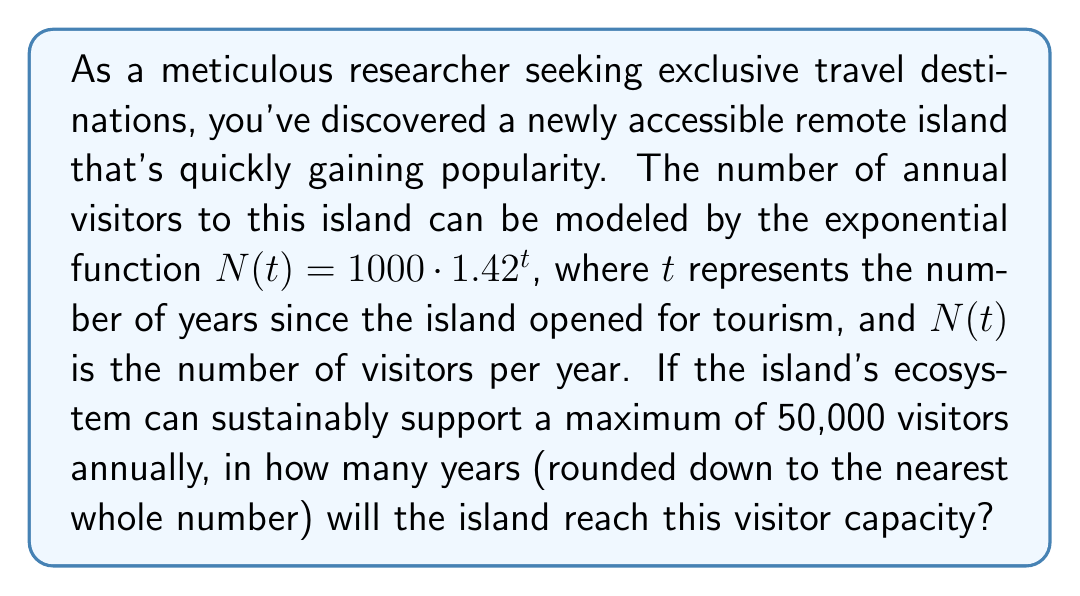Teach me how to tackle this problem. To solve this problem, we need to use the exponential function given and solve for $t$ when $N(t) = 50,000$. Let's break it down step by step:

1) We start with the equation:
   $N(t) = 1000 \cdot 1.42^t$

2) We want to find $t$ when $N(t) = 50,000$, so we set up the equation:
   $50,000 = 1000 \cdot 1.42^t$

3) Divide both sides by 1000:
   $50 = 1.42^t$

4) Now we need to solve for $t$. We can do this by taking the logarithm of both sides. Let's use the natural logarithm (ln):
   $\ln(50) = \ln(1.42^t)$

5) Using the logarithm property $\ln(a^b) = b\ln(a)$, we get:
   $\ln(50) = t \cdot \ln(1.42)$

6) Now we can solve for $t$:
   $t = \frac{\ln(50)}{\ln(1.42)}$

7) Using a calculator:
   $t \approx 10.6747$

8) Since we need to round down to the nearest whole number of years, our final answer is 10 years.
Answer: 10 years 